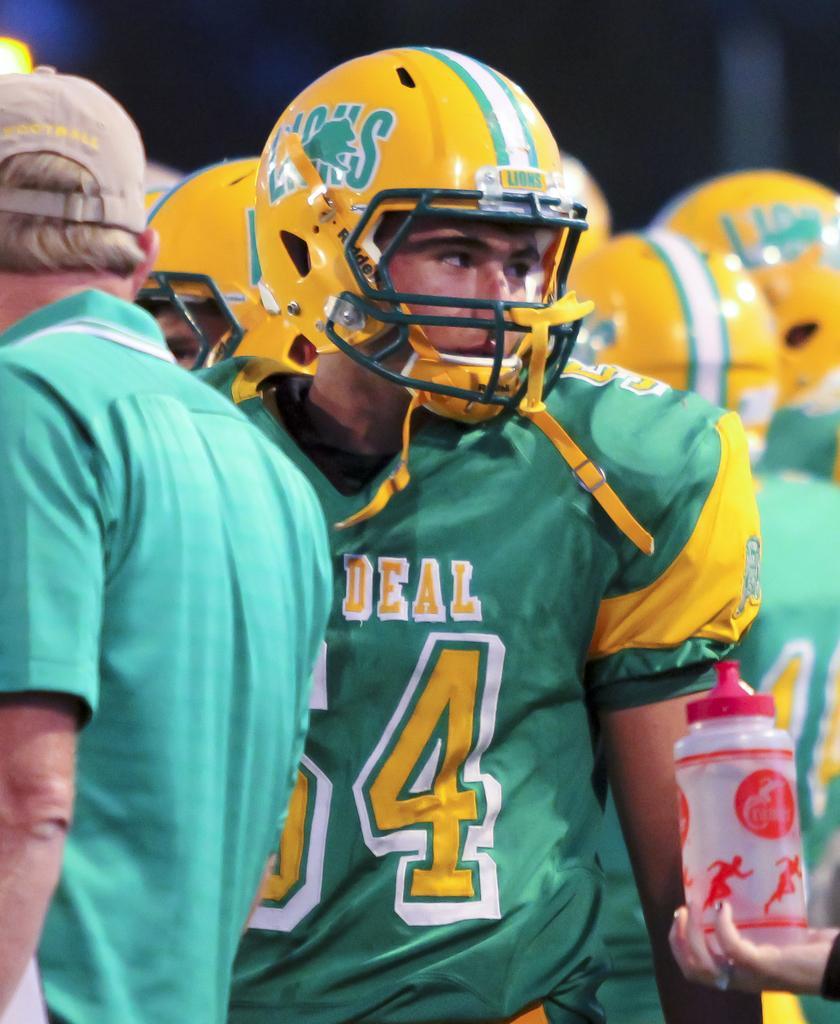Can you describe this image briefly? In this image there are group of persons standing and wearing helmets which are yellow in colour. On the right side there is a bottle in the hand of the person. 